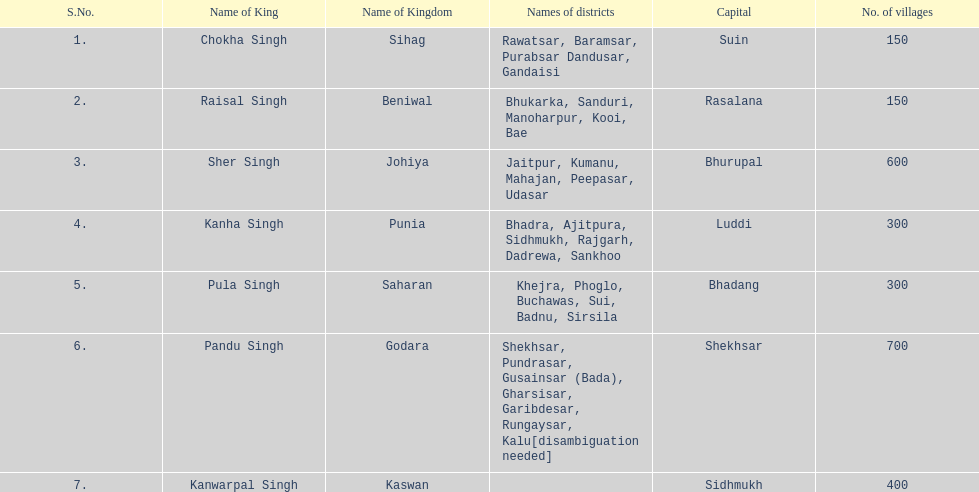Can you give me this table as a dict? {'header': ['S.No.', 'Name of King', 'Name of Kingdom', 'Names of districts', 'Capital', 'No. of villages'], 'rows': [['1.', 'Chokha Singh', 'Sihag', 'Rawatsar, Baramsar, Purabsar Dandusar, Gandaisi', 'Suin', '150'], ['2.', 'Raisal Singh', 'Beniwal', 'Bhukarka, Sanduri, Manoharpur, Kooi, Bae', 'Rasalana', '150'], ['3.', 'Sher Singh', 'Johiya', 'Jaitpur, Kumanu, Mahajan, Peepasar, Udasar', 'Bhurupal', '600'], ['4.', 'Kanha Singh', 'Punia', 'Bhadra, Ajitpura, Sidhmukh, Rajgarh, Dadrewa, Sankhoo', 'Luddi', '300'], ['5.', 'Pula Singh', 'Saharan', 'Khejra, Phoglo, Buchawas, Sui, Badnu, Sirsila', 'Bhadang', '300'], ['6.', 'Pandu Singh', 'Godara', 'Shekhsar, Pundrasar, Gusainsar (Bada), Gharsisar, Garibdesar, Rungaysar, Kalu[disambiguation needed]', 'Shekhsar', '700'], ['7.', 'Kanwarpal Singh', 'Kaswan', '', 'Sidhmukh', '400']]} What are the number of villages johiya has according to this chart? 600. 